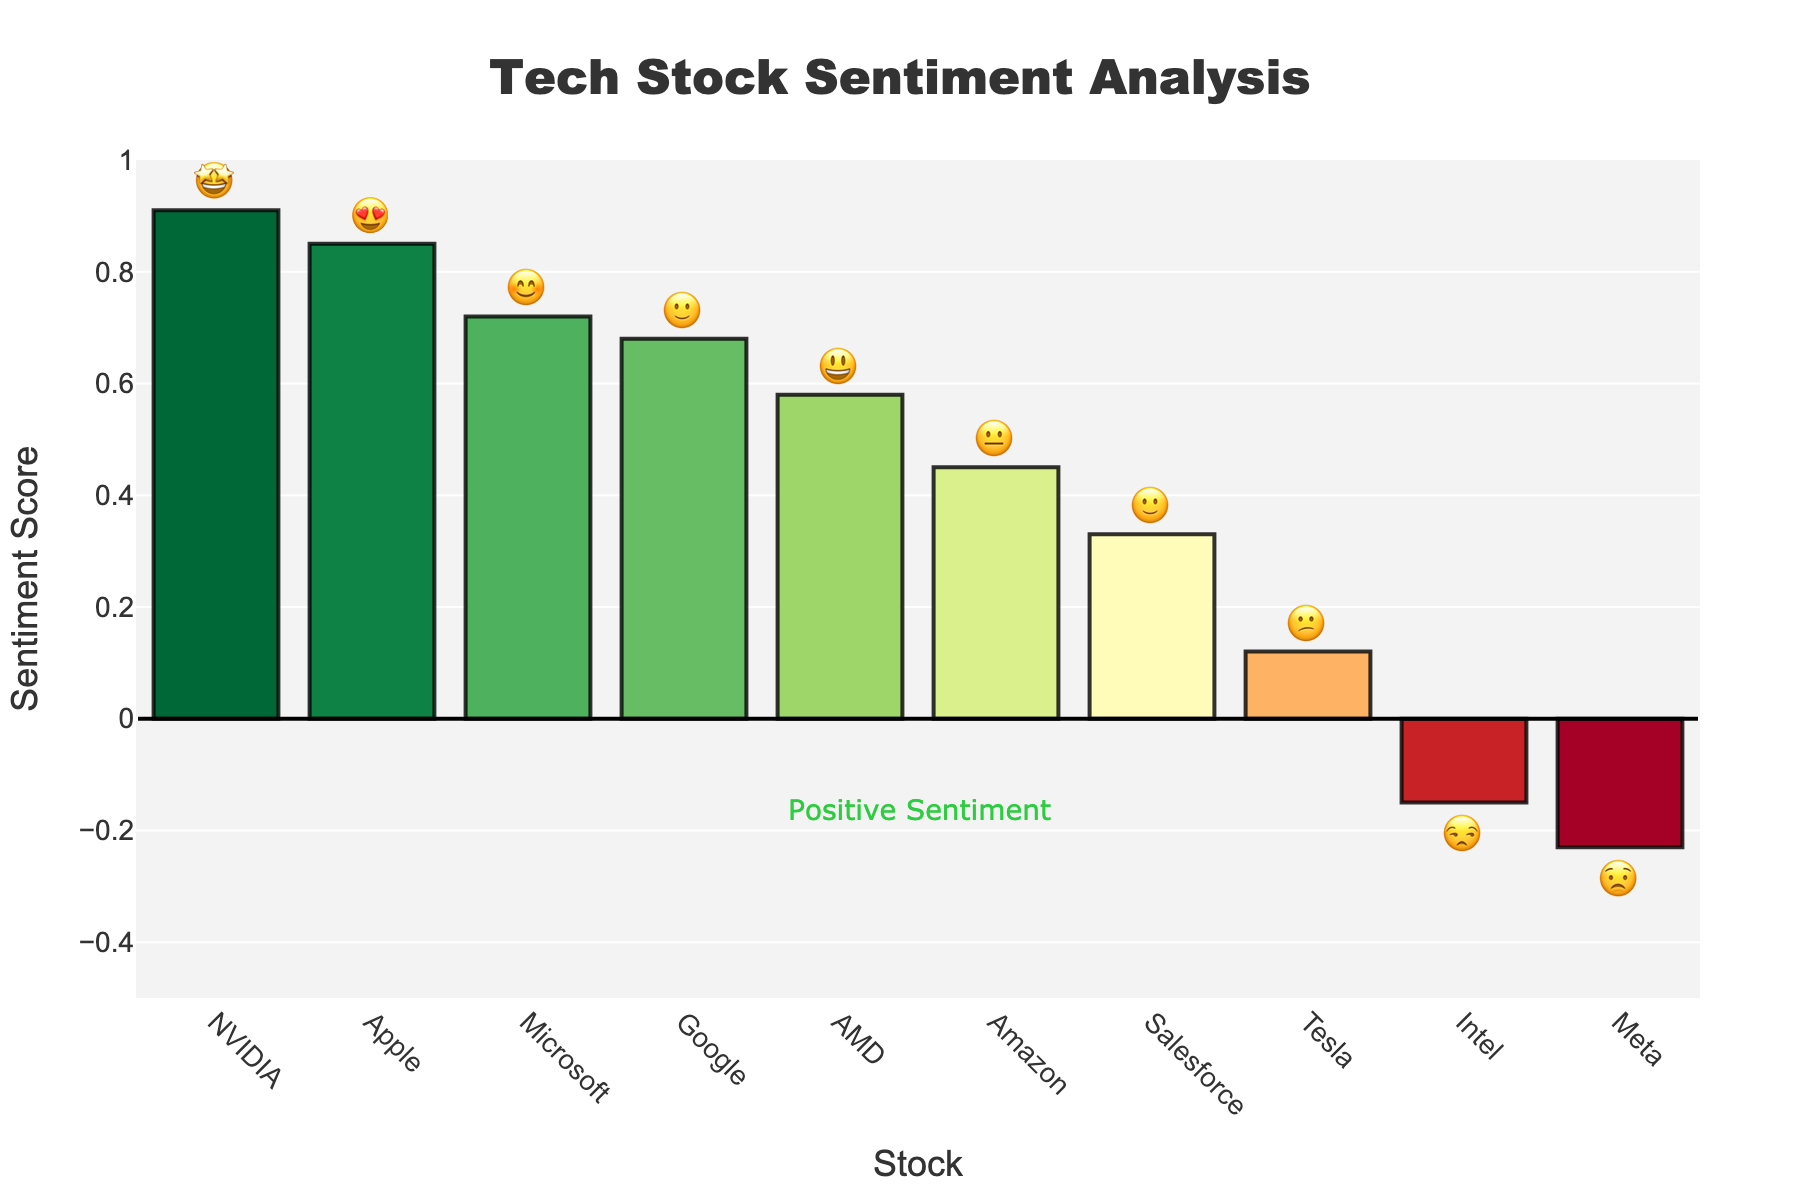What's the title of the plot? The title is typically displayed at the top of the plot and gives a summary of what the chart is about. In this case, it is labeled clearly.
Answer: Tech Stock Sentiment Analysis Which stock has the highest sentiment score? To find this, locate the bar with the highest value on the y-axis. The stock name on the x-axis corresponds to this bar. The highest bar is linked to NVIDIA.
Answer: NVIDIA What emoji represents Apple? The emoji for each stock is displayed at the top of each bar in the bar chart. Look for Apple on the x-axis and note the emoji above it.
Answer: 😍 How many stocks have a positive sentiment score? Positive sentiment scores are those above 0. Identify the bars that are above the y-axis value of 0. Count these bars to get the answer.
Answer: 8 Which stock has the lowest sentiment score, and what emoji represents it? First, find the bar with the lowest value on the y-axis to determine the stock. The corresponding emoji is displayed above this bar.
Answer: Meta, 😟 Compare the sentiment scores of Apple and Tesla. Which one is higher and by how much? Locate the bars for Apple and Tesla on the x-axis and compare their heights. Apple is higher. Subtract Tesla's score from Apple's score (0.85 - 0.12).
Answer: Apple is higher by 0.73 What is the range of sentiment scores represented in the plot? Identify the highest and lowest sentiment scores from the top and bottom of the bars respectively. Subtract the lowest score from the highest score (0.91 - (-0.23)).
Answer: 1.14 Which stocks have a sentiment score below zero, and what are their corresponding emojis? Look for bars that are below the y-axis value of 0. Note the corresponding stock names on the x-axis and their emojis above the bars.
Answer: Meta 😟, Intel 😒 What is the sentiment score for Microsoft? Locate the Microsoft bar on the x-axis and look at its height on the y-axis. If needed, refer to the hover info for exact detail.
Answer: 0.72 Calculate the average sentiment score of Amazon, Salesforce, and AMD. Find the sentiment scores for Amazon (0.45), Salesforce (0.33), and AMD (0.58). Add these values together and divide by 3 ((0.45 + 0.33 + 0.58)/3).
Answer: 0.453 